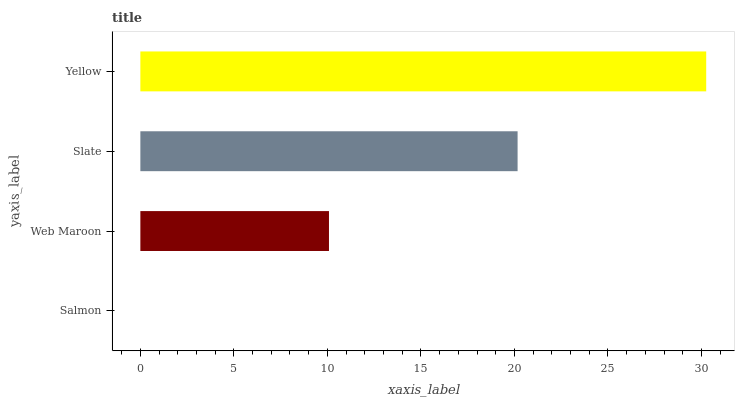Is Salmon the minimum?
Answer yes or no. Yes. Is Yellow the maximum?
Answer yes or no. Yes. Is Web Maroon the minimum?
Answer yes or no. No. Is Web Maroon the maximum?
Answer yes or no. No. Is Web Maroon greater than Salmon?
Answer yes or no. Yes. Is Salmon less than Web Maroon?
Answer yes or no. Yes. Is Salmon greater than Web Maroon?
Answer yes or no. No. Is Web Maroon less than Salmon?
Answer yes or no. No. Is Slate the high median?
Answer yes or no. Yes. Is Web Maroon the low median?
Answer yes or no. Yes. Is Web Maroon the high median?
Answer yes or no. No. Is Slate the low median?
Answer yes or no. No. 